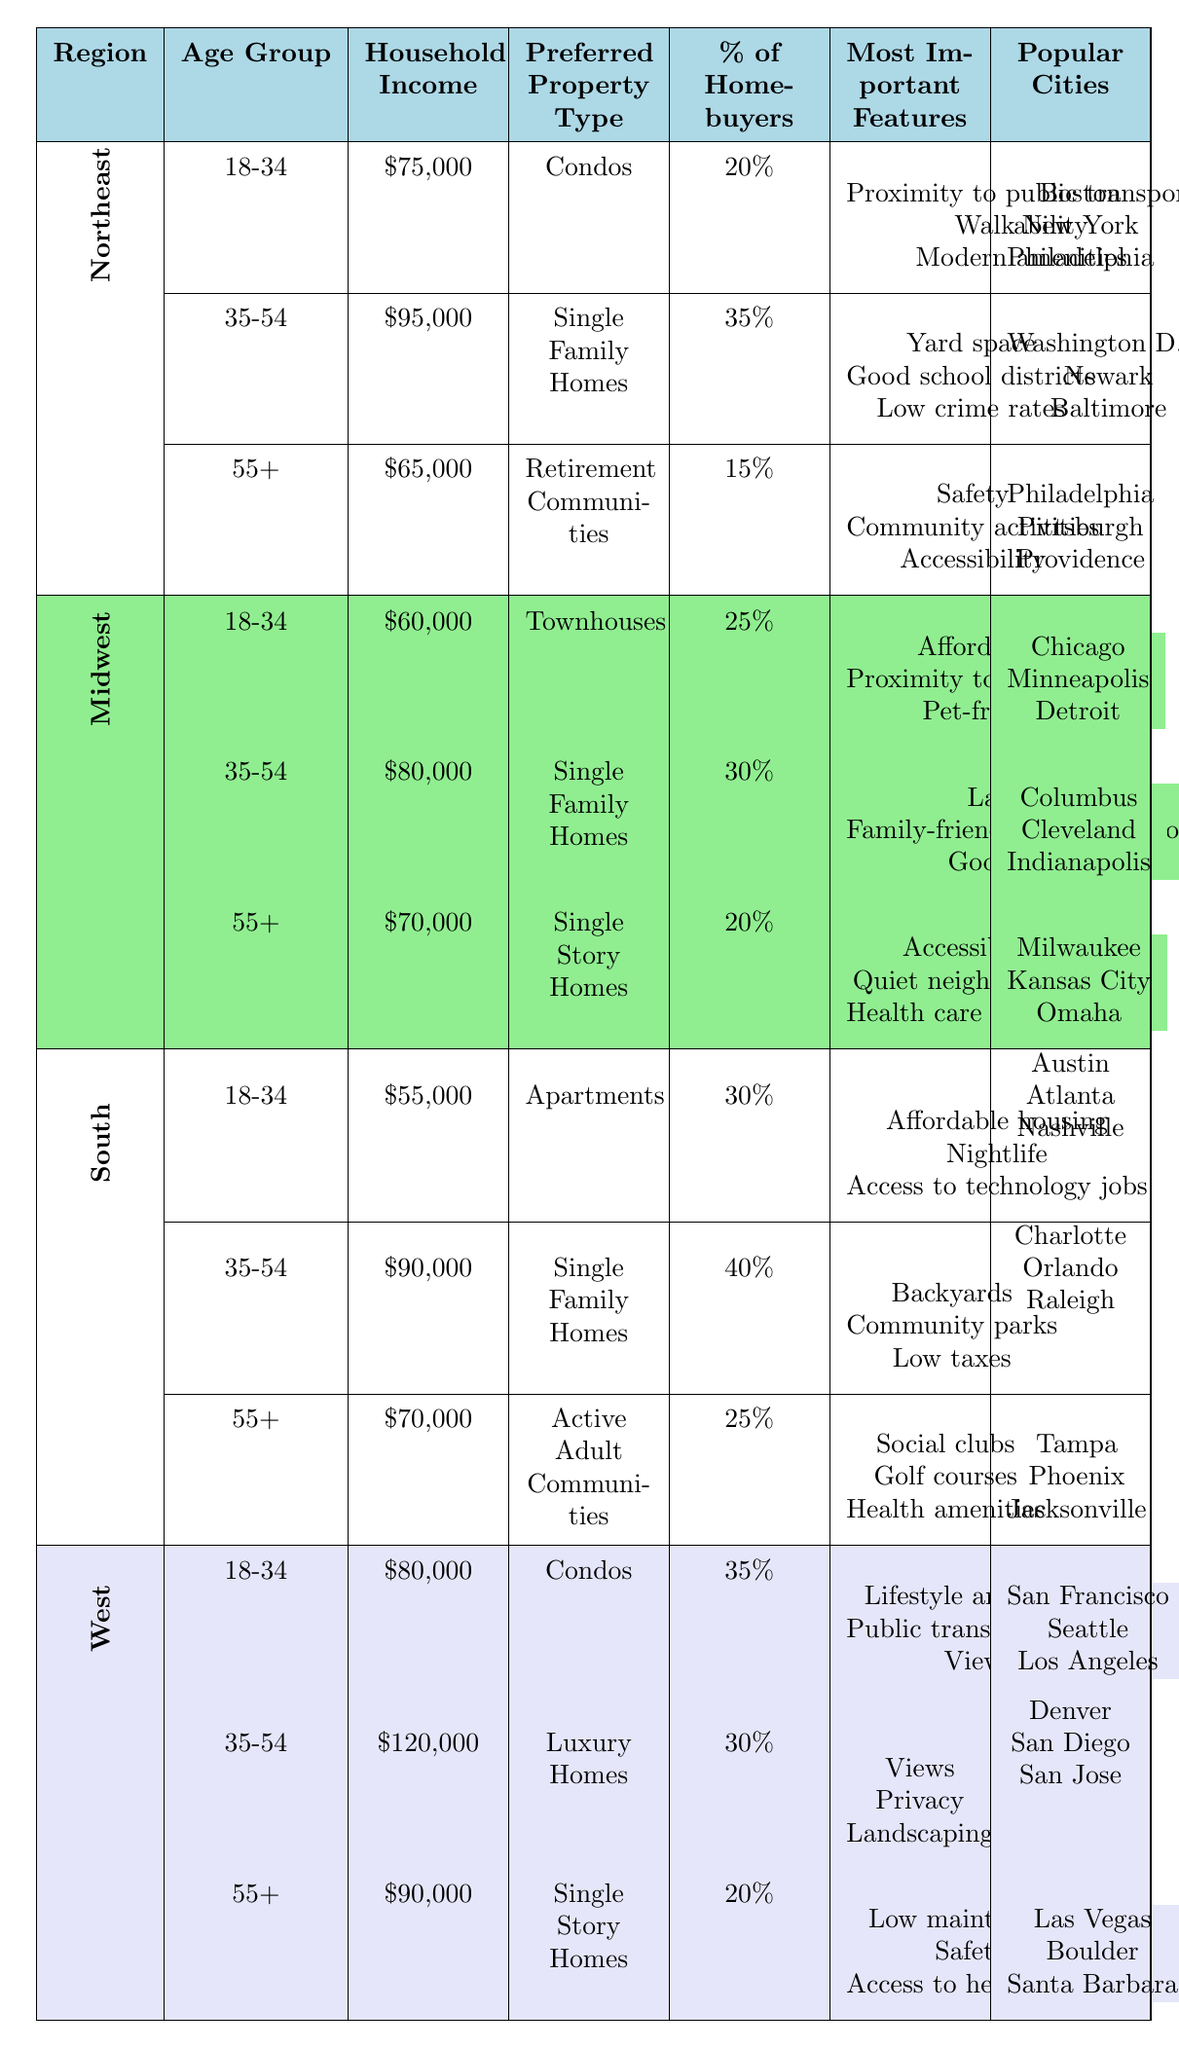What is the preferred property type for homebuyers aged 35-54 in the South? Referring to the South region, for the age group 35-54, the preferred property type is "Single Family Homes."
Answer: Single Family Homes Which region has the highest percentage of homebuyers aged 18-34? The table shows that the South region has 30% of homebuyers aged 18-34, whereas the West has 35%. Hence, the West has the highest percentage.
Answer: West What is the average household income of homebuyers across all regions for the age group 55+? Average income = (65,000 + 70,000 + 70,000 + 90,000) / 4 = 73,750. The individual incomes for this age group are summed up (65,000 for Northeast, 70,000 for Midwest, 70,000 for South, 90,000 for West) and divided by 4.
Answer: 73,750 Which age group in the Midwest has the lowest percentage of homebuyers? In the Midwest, the age group 55+ has the lowest percentage at 20%, compared to age groups 18-34 (25%) and 35-54 (30%).
Answer: 55+ Is it true that the majority of homebuyers in the Northeast prefer single family homes? In the Northeast region, 35% of homebuyers aged 35-54 prefer single family homes, while 20% of the 18-34 group prefer condos, leading to the conclusion that single family homes are favored, but not by the majority overall.
Answer: No What are the top three most important features for homebuyers in the West aged 18-34? For homebuyers in the West age group 18-34, the three most important features are lifestyle amenities, public transportation, and view. These are listed in the table under the respective demographic.
Answer: Lifestyle amenities, Public transportation, View Which region has the highest household income for the age group 35-54? The West region has a household income of $120,000 for the age group 35-54, which is higher than the Northeast ($95,000) and the South ($90,000).
Answer: West What percentage of homebuyers in the South prefer active adult communities? For the South region, 25% of homebuyers aged 55+ prefer active adult communities, according to the data presented.
Answer: 25% If we categorize preferred property types in the Midwest, how many prefer single family homes? In the Midwest, 30% from the age group 35-54 prefer single family homes, while the 55+ age group opts for single story homes at 20%. This totals 50% when combined.
Answer: 50% Which popular cities are preferred by homebuyers aged 18-34 in the Northeast? The popular cities for the 18-34 age group in the Northeast are Boston, New York, and Philadelphia, as specified in the table.
Answer: Boston, New York, Philadelphia What is the most important feature for homebuyers aged 55+ in the Northeast? The most important feature for this age group in the Northeast is safety, as mentioned in the table, along with community activities and accessibility as additional features.
Answer: Safety 